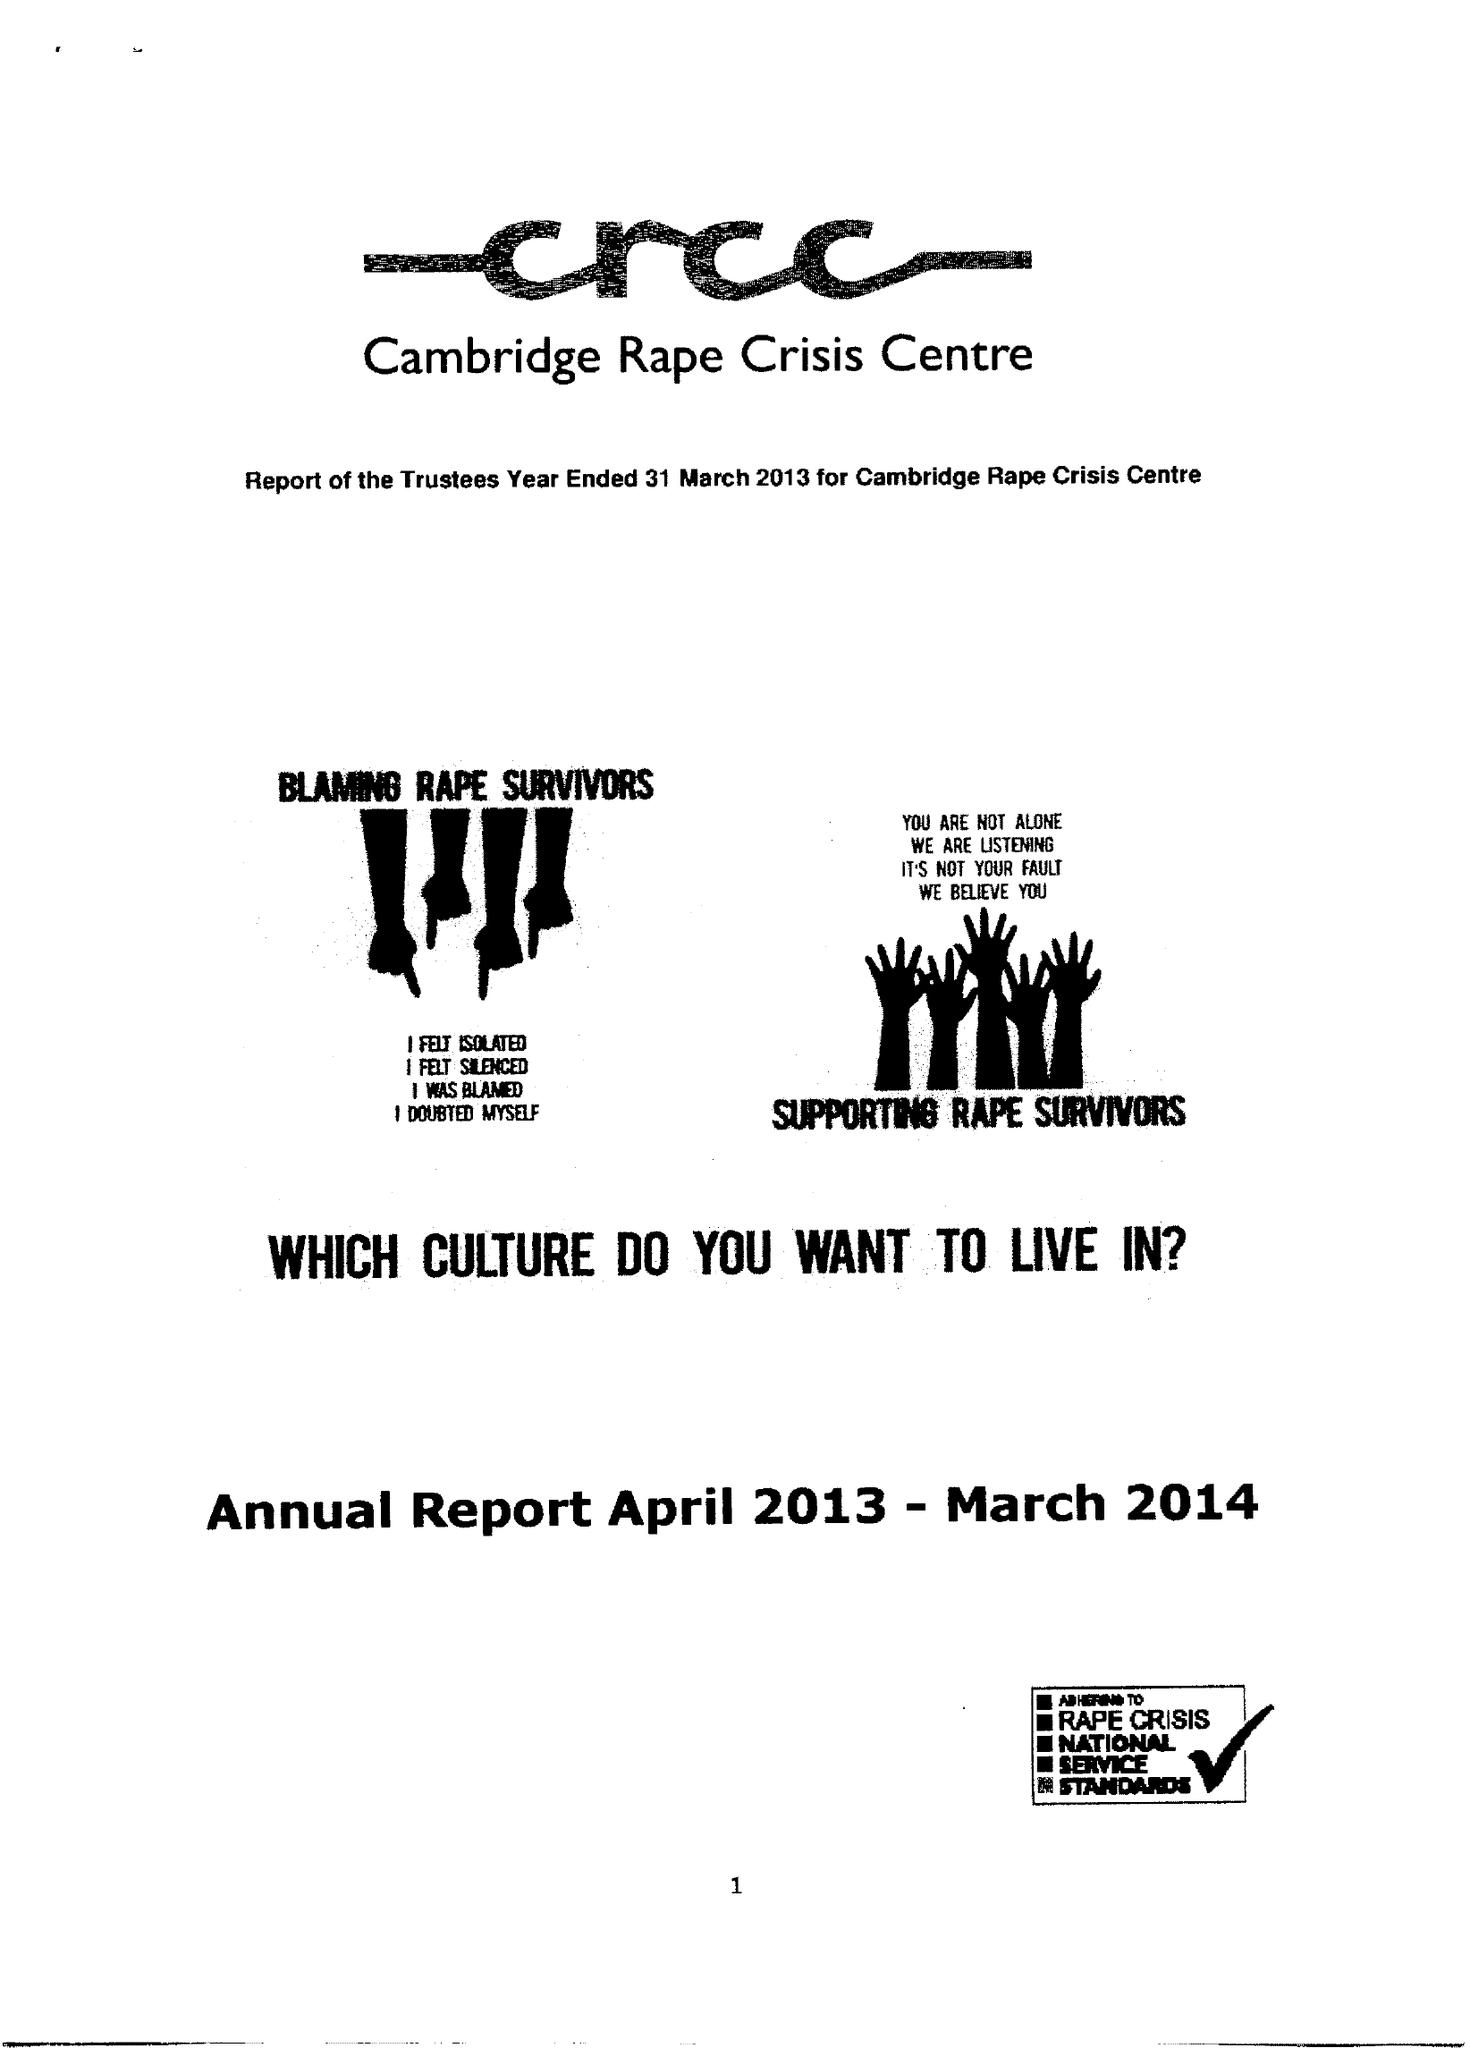What is the value for the charity_number?
Answer the question using a single word or phrase. 286098 